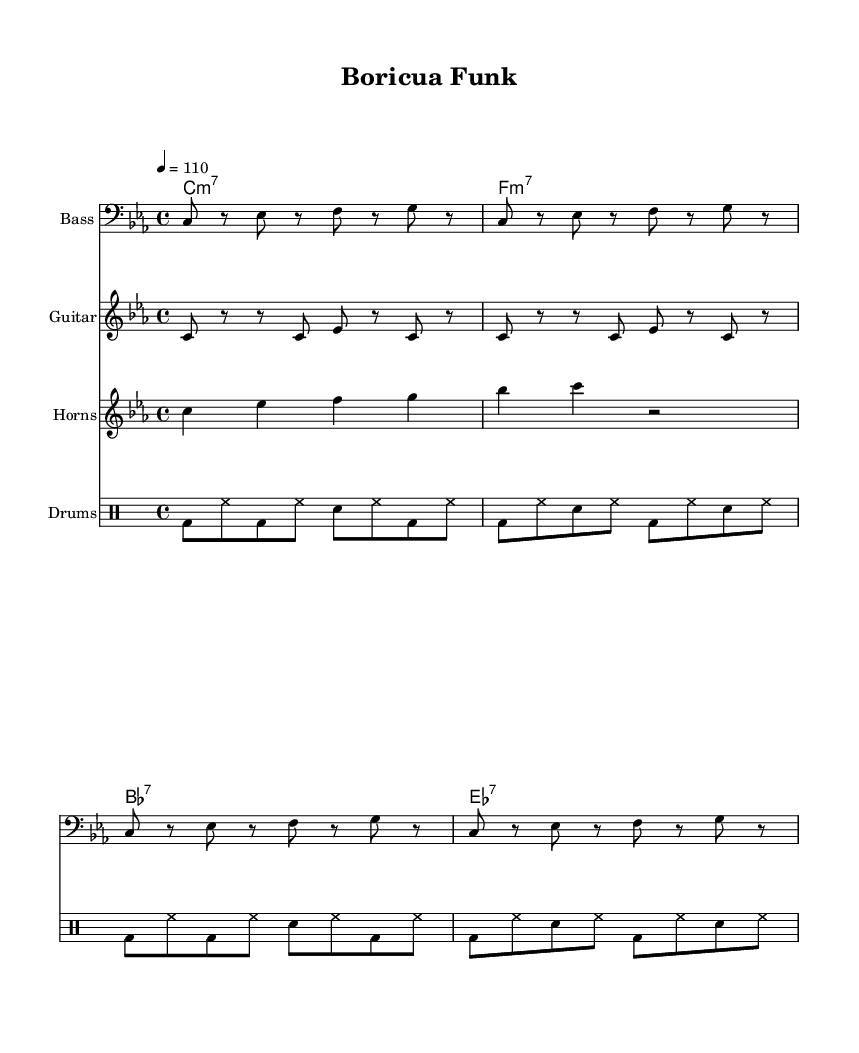What is the key signature of this music? The key signature indicates the music is in C minor, which has three flats (B flat, E flat, and A flat).
Answer: C minor What is the time signature of this piece? The time signature is 4/4, which means there are four beats in a measure and the quarter note gets one beat.
Answer: 4/4 What is the tempo marking of the piece? The tempo marking is specified as 110 beats per minute, which indicates how fast the piece should be played.
Answer: 110 How many bars are in the bass line pattern before it repeats? The bass line has a pattern that is repeated and consists of 4 measures, evidenced by the repeat symbol at the beginning.
Answer: 4 Which instruments are present in this score? The score includes the Bass, Guitar, Horns, and Drums, as indicated by their respective staff labels at the beginning of each line.
Answer: Bass, Guitar, Horns, Drums How many unique notes are in the horn section? The horn section contains four unique pitches: C, E flat, F, and G as noted in the staff.
Answer: Four What type of chords are used in this piece? The chord names indicate the use of minor seventh and dominant seventh chords, which are typical of funk music harmonies.
Answer: Minor seventh, Dominant seventh 